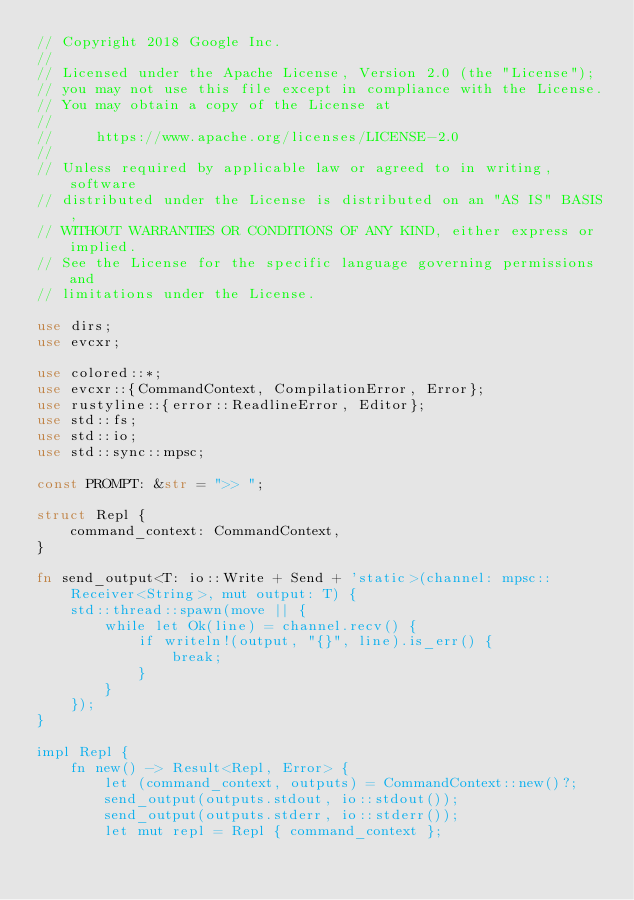<code> <loc_0><loc_0><loc_500><loc_500><_Rust_>// Copyright 2018 Google Inc.
//
// Licensed under the Apache License, Version 2.0 (the "License");
// you may not use this file except in compliance with the License.
// You may obtain a copy of the License at
//
//     https://www.apache.org/licenses/LICENSE-2.0
//
// Unless required by applicable law or agreed to in writing, software
// distributed under the License is distributed on an "AS IS" BASIS,
// WITHOUT WARRANTIES OR CONDITIONS OF ANY KIND, either express or implied.
// See the License for the specific language governing permissions and
// limitations under the License.

use dirs;
use evcxr;

use colored::*;
use evcxr::{CommandContext, CompilationError, Error};
use rustyline::{error::ReadlineError, Editor};
use std::fs;
use std::io;
use std::sync::mpsc;

const PROMPT: &str = ">> ";

struct Repl {
    command_context: CommandContext,
}

fn send_output<T: io::Write + Send + 'static>(channel: mpsc::Receiver<String>, mut output: T) {
    std::thread::spawn(move || {
        while let Ok(line) = channel.recv() {
            if writeln!(output, "{}", line).is_err() {
                break;
            }
        }
    });
}

impl Repl {
    fn new() -> Result<Repl, Error> {
        let (command_context, outputs) = CommandContext::new()?;
        send_output(outputs.stdout, io::stdout());
        send_output(outputs.stderr, io::stderr());
        let mut repl = Repl { command_context };</code> 